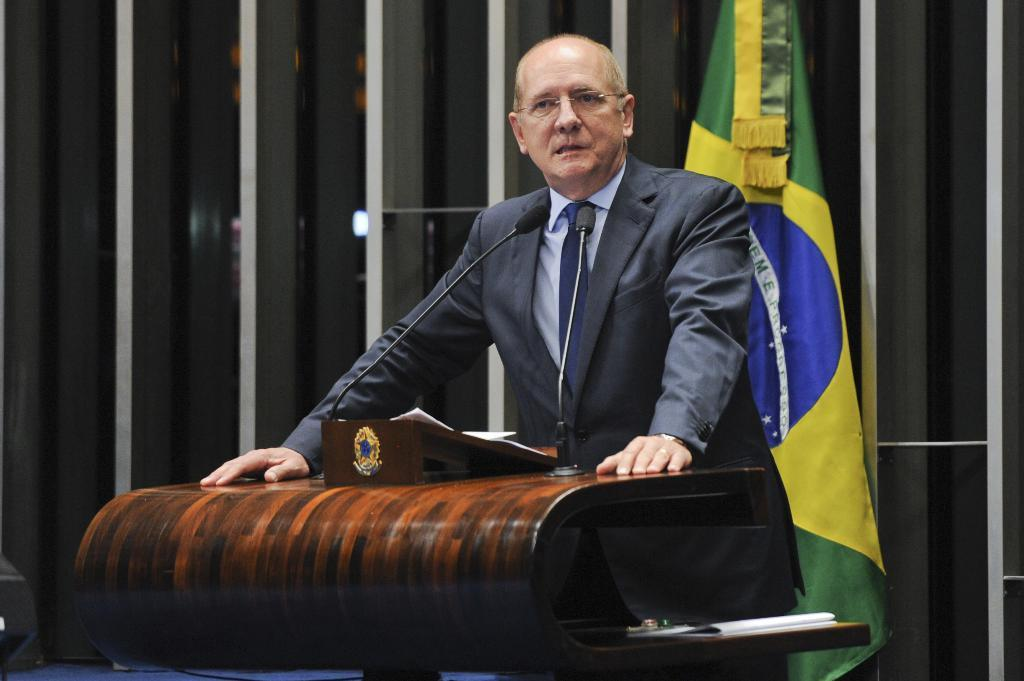What is the person in the image doing? The person is standing in front of a podium. What is on the podium with the person? There are microphones, a paper, and a book on the podium. What can be seen behind the person? There is a flag visible behind the person. How many pigs are visible in the image? There are no pigs present in the image. What type of map is being distributed by the person in the image? There is no map or distribution activity depicted in the image. 